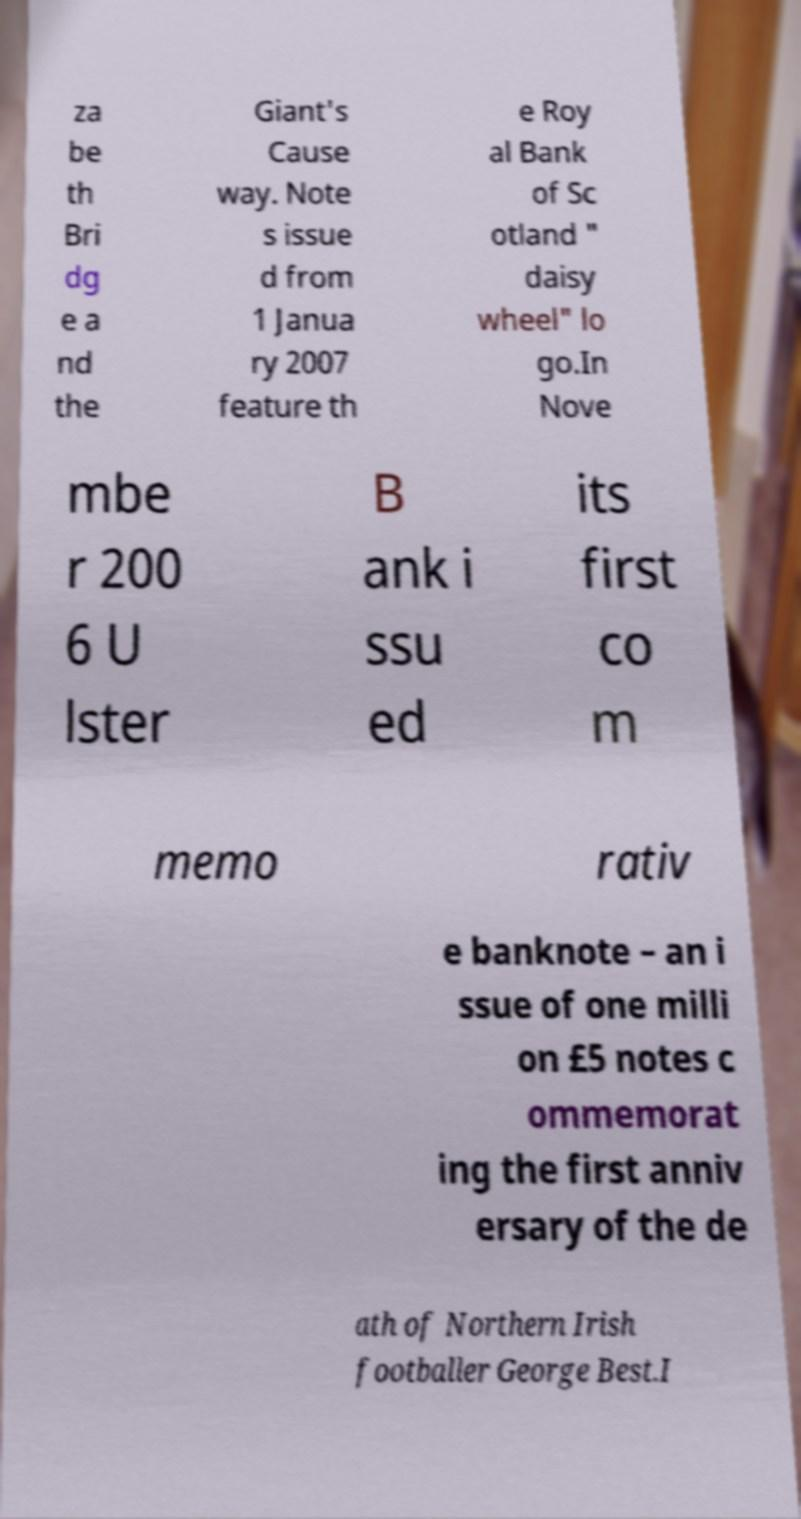Please read and relay the text visible in this image. What does it say? za be th Bri dg e a nd the Giant's Cause way. Note s issue d from 1 Janua ry 2007 feature th e Roy al Bank of Sc otland " daisy wheel" lo go.In Nove mbe r 200 6 U lster B ank i ssu ed its first co m memo rativ e banknote – an i ssue of one milli on £5 notes c ommemorat ing the first anniv ersary of the de ath of Northern Irish footballer George Best.I 